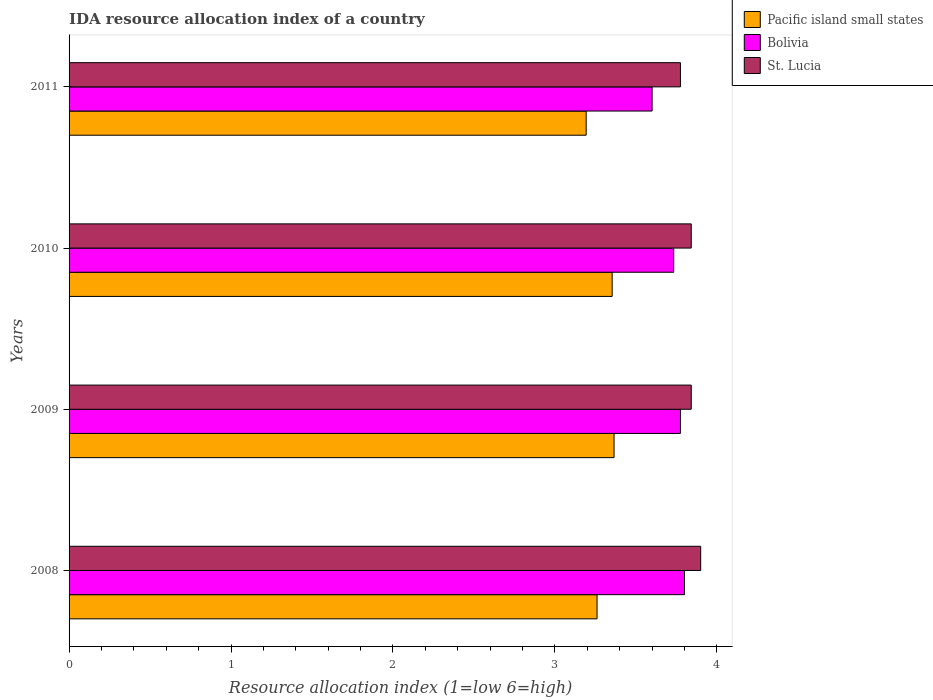How many different coloured bars are there?
Give a very brief answer. 3. Are the number of bars on each tick of the Y-axis equal?
Provide a succinct answer. Yes. How many bars are there on the 3rd tick from the top?
Your response must be concise. 3. What is the label of the 1st group of bars from the top?
Provide a succinct answer. 2011. In how many cases, is the number of bars for a given year not equal to the number of legend labels?
Offer a very short reply. 0. What is the IDA resource allocation index in St. Lucia in 2010?
Offer a terse response. 3.84. Across all years, what is the maximum IDA resource allocation index in Pacific island small states?
Offer a very short reply. 3.37. Across all years, what is the minimum IDA resource allocation index in St. Lucia?
Offer a terse response. 3.77. In which year was the IDA resource allocation index in St. Lucia minimum?
Make the answer very short. 2011. What is the total IDA resource allocation index in Pacific island small states in the graph?
Ensure brevity in your answer.  13.17. What is the difference between the IDA resource allocation index in Pacific island small states in 2008 and that in 2010?
Give a very brief answer. -0.09. What is the difference between the IDA resource allocation index in Bolivia in 2009 and the IDA resource allocation index in St. Lucia in 2011?
Offer a very short reply. 0. What is the average IDA resource allocation index in Bolivia per year?
Provide a succinct answer. 3.73. In the year 2010, what is the difference between the IDA resource allocation index in St. Lucia and IDA resource allocation index in Bolivia?
Offer a very short reply. 0.11. What is the ratio of the IDA resource allocation index in Pacific island small states in 2008 to that in 2010?
Offer a very short reply. 0.97. Is the IDA resource allocation index in Pacific island small states in 2008 less than that in 2011?
Your answer should be compact. No. Is the difference between the IDA resource allocation index in St. Lucia in 2010 and 2011 greater than the difference between the IDA resource allocation index in Bolivia in 2010 and 2011?
Provide a short and direct response. No. What is the difference between the highest and the second highest IDA resource allocation index in Bolivia?
Your answer should be very brief. 0.02. What is the difference between the highest and the lowest IDA resource allocation index in Pacific island small states?
Provide a short and direct response. 0.17. In how many years, is the IDA resource allocation index in Pacific island small states greater than the average IDA resource allocation index in Pacific island small states taken over all years?
Keep it short and to the point. 2. Is the sum of the IDA resource allocation index in Bolivia in 2009 and 2010 greater than the maximum IDA resource allocation index in Pacific island small states across all years?
Offer a terse response. Yes. What does the 3rd bar from the top in 2008 represents?
Make the answer very short. Pacific island small states. What does the 2nd bar from the bottom in 2009 represents?
Offer a terse response. Bolivia. Is it the case that in every year, the sum of the IDA resource allocation index in Pacific island small states and IDA resource allocation index in St. Lucia is greater than the IDA resource allocation index in Bolivia?
Make the answer very short. Yes. Are all the bars in the graph horizontal?
Your answer should be very brief. Yes. Does the graph contain any zero values?
Your answer should be compact. No. Does the graph contain grids?
Make the answer very short. No. How many legend labels are there?
Give a very brief answer. 3. How are the legend labels stacked?
Offer a terse response. Vertical. What is the title of the graph?
Ensure brevity in your answer.  IDA resource allocation index of a country. What is the label or title of the X-axis?
Offer a very short reply. Resource allocation index (1=low 6=high). What is the label or title of the Y-axis?
Ensure brevity in your answer.  Years. What is the Resource allocation index (1=low 6=high) of Pacific island small states in 2008?
Your answer should be compact. 3.26. What is the Resource allocation index (1=low 6=high) of Bolivia in 2008?
Provide a succinct answer. 3.8. What is the Resource allocation index (1=low 6=high) in Pacific island small states in 2009?
Keep it short and to the point. 3.37. What is the Resource allocation index (1=low 6=high) of Bolivia in 2009?
Your response must be concise. 3.77. What is the Resource allocation index (1=low 6=high) of St. Lucia in 2009?
Give a very brief answer. 3.84. What is the Resource allocation index (1=low 6=high) in Pacific island small states in 2010?
Provide a short and direct response. 3.35. What is the Resource allocation index (1=low 6=high) in Bolivia in 2010?
Give a very brief answer. 3.73. What is the Resource allocation index (1=low 6=high) in St. Lucia in 2010?
Provide a succinct answer. 3.84. What is the Resource allocation index (1=low 6=high) in Pacific island small states in 2011?
Your response must be concise. 3.19. What is the Resource allocation index (1=low 6=high) in St. Lucia in 2011?
Provide a succinct answer. 3.77. Across all years, what is the maximum Resource allocation index (1=low 6=high) in Pacific island small states?
Ensure brevity in your answer.  3.37. Across all years, what is the maximum Resource allocation index (1=low 6=high) of Bolivia?
Provide a short and direct response. 3.8. Across all years, what is the maximum Resource allocation index (1=low 6=high) of St. Lucia?
Provide a succinct answer. 3.9. Across all years, what is the minimum Resource allocation index (1=low 6=high) of Pacific island small states?
Your answer should be very brief. 3.19. Across all years, what is the minimum Resource allocation index (1=low 6=high) of Bolivia?
Offer a terse response. 3.6. Across all years, what is the minimum Resource allocation index (1=low 6=high) in St. Lucia?
Make the answer very short. 3.77. What is the total Resource allocation index (1=low 6=high) in Pacific island small states in the graph?
Offer a terse response. 13.17. What is the total Resource allocation index (1=low 6=high) of Bolivia in the graph?
Provide a succinct answer. 14.91. What is the total Resource allocation index (1=low 6=high) in St. Lucia in the graph?
Give a very brief answer. 15.36. What is the difference between the Resource allocation index (1=low 6=high) in Pacific island small states in 2008 and that in 2009?
Offer a terse response. -0.1. What is the difference between the Resource allocation index (1=low 6=high) of Bolivia in 2008 and that in 2009?
Your response must be concise. 0.03. What is the difference between the Resource allocation index (1=low 6=high) of St. Lucia in 2008 and that in 2009?
Ensure brevity in your answer.  0.06. What is the difference between the Resource allocation index (1=low 6=high) of Pacific island small states in 2008 and that in 2010?
Your response must be concise. -0.09. What is the difference between the Resource allocation index (1=low 6=high) in Bolivia in 2008 and that in 2010?
Ensure brevity in your answer.  0.07. What is the difference between the Resource allocation index (1=low 6=high) in St. Lucia in 2008 and that in 2010?
Make the answer very short. 0.06. What is the difference between the Resource allocation index (1=low 6=high) in Pacific island small states in 2008 and that in 2011?
Provide a succinct answer. 0.07. What is the difference between the Resource allocation index (1=low 6=high) in Bolivia in 2008 and that in 2011?
Provide a short and direct response. 0.2. What is the difference between the Resource allocation index (1=low 6=high) in Pacific island small states in 2009 and that in 2010?
Make the answer very short. 0.01. What is the difference between the Resource allocation index (1=low 6=high) in Bolivia in 2009 and that in 2010?
Make the answer very short. 0.04. What is the difference between the Resource allocation index (1=low 6=high) of St. Lucia in 2009 and that in 2010?
Your response must be concise. 0. What is the difference between the Resource allocation index (1=low 6=high) in Pacific island small states in 2009 and that in 2011?
Give a very brief answer. 0.17. What is the difference between the Resource allocation index (1=low 6=high) in Bolivia in 2009 and that in 2011?
Provide a succinct answer. 0.17. What is the difference between the Resource allocation index (1=low 6=high) in St. Lucia in 2009 and that in 2011?
Keep it short and to the point. 0.07. What is the difference between the Resource allocation index (1=low 6=high) in Pacific island small states in 2010 and that in 2011?
Your answer should be compact. 0.16. What is the difference between the Resource allocation index (1=low 6=high) in Bolivia in 2010 and that in 2011?
Your answer should be very brief. 0.13. What is the difference between the Resource allocation index (1=low 6=high) of St. Lucia in 2010 and that in 2011?
Ensure brevity in your answer.  0.07. What is the difference between the Resource allocation index (1=low 6=high) in Pacific island small states in 2008 and the Resource allocation index (1=low 6=high) in Bolivia in 2009?
Provide a short and direct response. -0.52. What is the difference between the Resource allocation index (1=low 6=high) of Pacific island small states in 2008 and the Resource allocation index (1=low 6=high) of St. Lucia in 2009?
Make the answer very short. -0.58. What is the difference between the Resource allocation index (1=low 6=high) in Bolivia in 2008 and the Resource allocation index (1=low 6=high) in St. Lucia in 2009?
Your response must be concise. -0.04. What is the difference between the Resource allocation index (1=low 6=high) in Pacific island small states in 2008 and the Resource allocation index (1=low 6=high) in Bolivia in 2010?
Ensure brevity in your answer.  -0.47. What is the difference between the Resource allocation index (1=low 6=high) in Pacific island small states in 2008 and the Resource allocation index (1=low 6=high) in St. Lucia in 2010?
Make the answer very short. -0.58. What is the difference between the Resource allocation index (1=low 6=high) of Bolivia in 2008 and the Resource allocation index (1=low 6=high) of St. Lucia in 2010?
Your answer should be very brief. -0.04. What is the difference between the Resource allocation index (1=low 6=high) of Pacific island small states in 2008 and the Resource allocation index (1=low 6=high) of Bolivia in 2011?
Your answer should be very brief. -0.34. What is the difference between the Resource allocation index (1=low 6=high) in Pacific island small states in 2008 and the Resource allocation index (1=low 6=high) in St. Lucia in 2011?
Your response must be concise. -0.52. What is the difference between the Resource allocation index (1=low 6=high) in Bolivia in 2008 and the Resource allocation index (1=low 6=high) in St. Lucia in 2011?
Make the answer very short. 0.03. What is the difference between the Resource allocation index (1=low 6=high) of Pacific island small states in 2009 and the Resource allocation index (1=low 6=high) of Bolivia in 2010?
Provide a short and direct response. -0.37. What is the difference between the Resource allocation index (1=low 6=high) of Pacific island small states in 2009 and the Resource allocation index (1=low 6=high) of St. Lucia in 2010?
Your response must be concise. -0.48. What is the difference between the Resource allocation index (1=low 6=high) in Bolivia in 2009 and the Resource allocation index (1=low 6=high) in St. Lucia in 2010?
Ensure brevity in your answer.  -0.07. What is the difference between the Resource allocation index (1=low 6=high) in Pacific island small states in 2009 and the Resource allocation index (1=low 6=high) in Bolivia in 2011?
Your answer should be compact. -0.23. What is the difference between the Resource allocation index (1=low 6=high) in Pacific island small states in 2009 and the Resource allocation index (1=low 6=high) in St. Lucia in 2011?
Your answer should be compact. -0.41. What is the difference between the Resource allocation index (1=low 6=high) in Bolivia in 2009 and the Resource allocation index (1=low 6=high) in St. Lucia in 2011?
Ensure brevity in your answer.  0. What is the difference between the Resource allocation index (1=low 6=high) of Pacific island small states in 2010 and the Resource allocation index (1=low 6=high) of Bolivia in 2011?
Ensure brevity in your answer.  -0.25. What is the difference between the Resource allocation index (1=low 6=high) of Pacific island small states in 2010 and the Resource allocation index (1=low 6=high) of St. Lucia in 2011?
Ensure brevity in your answer.  -0.42. What is the difference between the Resource allocation index (1=low 6=high) of Bolivia in 2010 and the Resource allocation index (1=low 6=high) of St. Lucia in 2011?
Make the answer very short. -0.04. What is the average Resource allocation index (1=low 6=high) in Pacific island small states per year?
Your response must be concise. 3.29. What is the average Resource allocation index (1=low 6=high) in Bolivia per year?
Keep it short and to the point. 3.73. What is the average Resource allocation index (1=low 6=high) in St. Lucia per year?
Your answer should be compact. 3.84. In the year 2008, what is the difference between the Resource allocation index (1=low 6=high) of Pacific island small states and Resource allocation index (1=low 6=high) of Bolivia?
Give a very brief answer. -0.54. In the year 2008, what is the difference between the Resource allocation index (1=low 6=high) in Pacific island small states and Resource allocation index (1=low 6=high) in St. Lucia?
Offer a terse response. -0.64. In the year 2008, what is the difference between the Resource allocation index (1=low 6=high) of Bolivia and Resource allocation index (1=low 6=high) of St. Lucia?
Your answer should be very brief. -0.1. In the year 2009, what is the difference between the Resource allocation index (1=low 6=high) of Pacific island small states and Resource allocation index (1=low 6=high) of Bolivia?
Your response must be concise. -0.41. In the year 2009, what is the difference between the Resource allocation index (1=low 6=high) in Pacific island small states and Resource allocation index (1=low 6=high) in St. Lucia?
Offer a terse response. -0.48. In the year 2009, what is the difference between the Resource allocation index (1=low 6=high) in Bolivia and Resource allocation index (1=low 6=high) in St. Lucia?
Offer a very short reply. -0.07. In the year 2010, what is the difference between the Resource allocation index (1=low 6=high) in Pacific island small states and Resource allocation index (1=low 6=high) in Bolivia?
Ensure brevity in your answer.  -0.38. In the year 2010, what is the difference between the Resource allocation index (1=low 6=high) in Pacific island small states and Resource allocation index (1=low 6=high) in St. Lucia?
Offer a terse response. -0.49. In the year 2010, what is the difference between the Resource allocation index (1=low 6=high) in Bolivia and Resource allocation index (1=low 6=high) in St. Lucia?
Offer a terse response. -0.11. In the year 2011, what is the difference between the Resource allocation index (1=low 6=high) of Pacific island small states and Resource allocation index (1=low 6=high) of Bolivia?
Provide a short and direct response. -0.41. In the year 2011, what is the difference between the Resource allocation index (1=low 6=high) of Pacific island small states and Resource allocation index (1=low 6=high) of St. Lucia?
Your answer should be very brief. -0.58. In the year 2011, what is the difference between the Resource allocation index (1=low 6=high) of Bolivia and Resource allocation index (1=low 6=high) of St. Lucia?
Offer a very short reply. -0.17. What is the ratio of the Resource allocation index (1=low 6=high) in Pacific island small states in 2008 to that in 2009?
Provide a succinct answer. 0.97. What is the ratio of the Resource allocation index (1=low 6=high) in Bolivia in 2008 to that in 2009?
Ensure brevity in your answer.  1.01. What is the ratio of the Resource allocation index (1=low 6=high) in St. Lucia in 2008 to that in 2009?
Make the answer very short. 1.02. What is the ratio of the Resource allocation index (1=low 6=high) of Pacific island small states in 2008 to that in 2010?
Offer a very short reply. 0.97. What is the ratio of the Resource allocation index (1=low 6=high) in Bolivia in 2008 to that in 2010?
Offer a very short reply. 1.02. What is the ratio of the Resource allocation index (1=low 6=high) in St. Lucia in 2008 to that in 2010?
Ensure brevity in your answer.  1.02. What is the ratio of the Resource allocation index (1=low 6=high) in Pacific island small states in 2008 to that in 2011?
Make the answer very short. 1.02. What is the ratio of the Resource allocation index (1=low 6=high) of Bolivia in 2008 to that in 2011?
Give a very brief answer. 1.06. What is the ratio of the Resource allocation index (1=low 6=high) in St. Lucia in 2008 to that in 2011?
Provide a succinct answer. 1.03. What is the ratio of the Resource allocation index (1=low 6=high) of Pacific island small states in 2009 to that in 2010?
Keep it short and to the point. 1. What is the ratio of the Resource allocation index (1=low 6=high) of Bolivia in 2009 to that in 2010?
Your answer should be compact. 1.01. What is the ratio of the Resource allocation index (1=low 6=high) in Pacific island small states in 2009 to that in 2011?
Offer a very short reply. 1.05. What is the ratio of the Resource allocation index (1=low 6=high) of Bolivia in 2009 to that in 2011?
Provide a short and direct response. 1.05. What is the ratio of the Resource allocation index (1=low 6=high) of St. Lucia in 2009 to that in 2011?
Ensure brevity in your answer.  1.02. What is the ratio of the Resource allocation index (1=low 6=high) of Pacific island small states in 2010 to that in 2011?
Offer a very short reply. 1.05. What is the ratio of the Resource allocation index (1=low 6=high) of St. Lucia in 2010 to that in 2011?
Provide a succinct answer. 1.02. What is the difference between the highest and the second highest Resource allocation index (1=low 6=high) of Pacific island small states?
Give a very brief answer. 0.01. What is the difference between the highest and the second highest Resource allocation index (1=low 6=high) of Bolivia?
Provide a succinct answer. 0.03. What is the difference between the highest and the second highest Resource allocation index (1=low 6=high) of St. Lucia?
Offer a very short reply. 0.06. What is the difference between the highest and the lowest Resource allocation index (1=low 6=high) of Pacific island small states?
Make the answer very short. 0.17. 